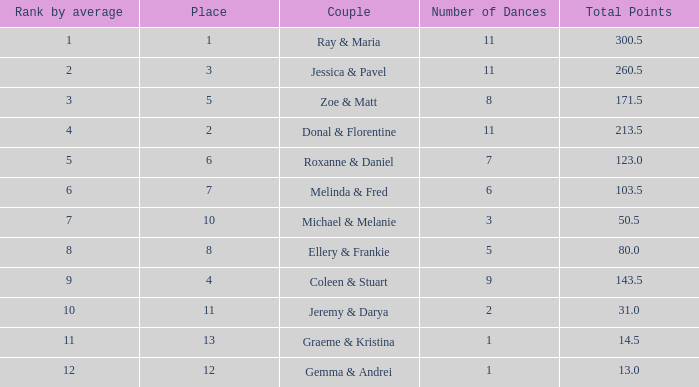If your standing by average is 9, what is the name of the duo? Coleen & Stuart. 